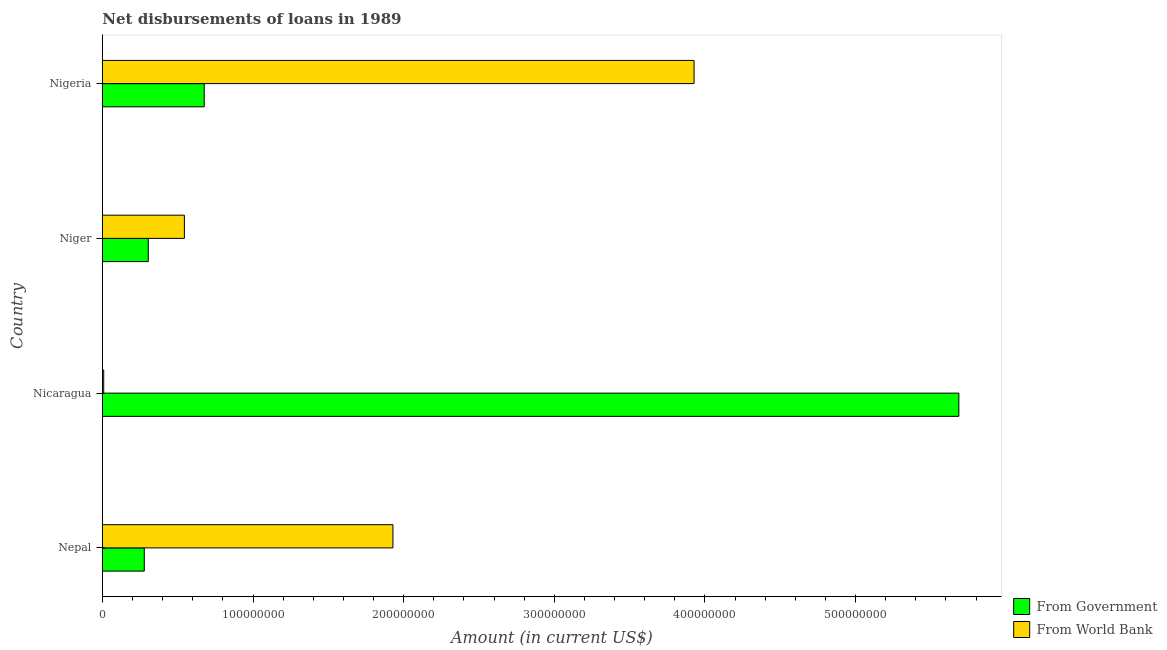How many different coloured bars are there?
Your response must be concise. 2. How many bars are there on the 3rd tick from the bottom?
Offer a terse response. 2. What is the label of the 4th group of bars from the top?
Provide a succinct answer. Nepal. What is the net disbursements of loan from world bank in Nigeria?
Offer a terse response. 3.93e+08. Across all countries, what is the maximum net disbursements of loan from government?
Keep it short and to the point. 5.69e+08. Across all countries, what is the minimum net disbursements of loan from world bank?
Offer a very short reply. 8.31e+05. In which country was the net disbursements of loan from world bank maximum?
Your response must be concise. Nigeria. In which country was the net disbursements of loan from world bank minimum?
Ensure brevity in your answer.  Nicaragua. What is the total net disbursements of loan from government in the graph?
Make the answer very short. 6.94e+08. What is the difference between the net disbursements of loan from government in Nicaragua and that in Niger?
Your response must be concise. 5.38e+08. What is the difference between the net disbursements of loan from world bank in Nigeria and the net disbursements of loan from government in Nicaragua?
Give a very brief answer. -1.76e+08. What is the average net disbursements of loan from government per country?
Provide a succinct answer. 1.74e+08. What is the difference between the net disbursements of loan from government and net disbursements of loan from world bank in Nepal?
Keep it short and to the point. -1.65e+08. What is the ratio of the net disbursements of loan from government in Nepal to that in Niger?
Ensure brevity in your answer.  0.91. What is the difference between the highest and the second highest net disbursements of loan from government?
Provide a short and direct response. 5.01e+08. What is the difference between the highest and the lowest net disbursements of loan from government?
Keep it short and to the point. 5.41e+08. In how many countries, is the net disbursements of loan from government greater than the average net disbursements of loan from government taken over all countries?
Your answer should be compact. 1. Is the sum of the net disbursements of loan from world bank in Nepal and Niger greater than the maximum net disbursements of loan from government across all countries?
Your answer should be compact. No. What does the 2nd bar from the top in Nigeria represents?
Provide a succinct answer. From Government. What does the 1st bar from the bottom in Niger represents?
Give a very brief answer. From Government. Are all the bars in the graph horizontal?
Ensure brevity in your answer.  Yes. How many countries are there in the graph?
Your answer should be compact. 4. What is the difference between two consecutive major ticks on the X-axis?
Keep it short and to the point. 1.00e+08. Does the graph contain any zero values?
Provide a succinct answer. No. Does the graph contain grids?
Make the answer very short. No. Where does the legend appear in the graph?
Keep it short and to the point. Bottom right. How many legend labels are there?
Your answer should be compact. 2. How are the legend labels stacked?
Offer a terse response. Vertical. What is the title of the graph?
Offer a terse response. Net disbursements of loans in 1989. What is the label or title of the Y-axis?
Your answer should be compact. Country. What is the Amount (in current US$) in From Government in Nepal?
Ensure brevity in your answer.  2.78e+07. What is the Amount (in current US$) of From World Bank in Nepal?
Your answer should be compact. 1.93e+08. What is the Amount (in current US$) in From Government in Nicaragua?
Provide a succinct answer. 5.69e+08. What is the Amount (in current US$) in From World Bank in Nicaragua?
Your answer should be very brief. 8.31e+05. What is the Amount (in current US$) of From Government in Niger?
Your answer should be compact. 3.04e+07. What is the Amount (in current US$) in From World Bank in Niger?
Provide a succinct answer. 5.44e+07. What is the Amount (in current US$) in From Government in Nigeria?
Provide a short and direct response. 6.76e+07. What is the Amount (in current US$) of From World Bank in Nigeria?
Your response must be concise. 3.93e+08. Across all countries, what is the maximum Amount (in current US$) of From Government?
Make the answer very short. 5.69e+08. Across all countries, what is the maximum Amount (in current US$) of From World Bank?
Provide a succinct answer. 3.93e+08. Across all countries, what is the minimum Amount (in current US$) in From Government?
Provide a short and direct response. 2.78e+07. Across all countries, what is the minimum Amount (in current US$) in From World Bank?
Your answer should be very brief. 8.31e+05. What is the total Amount (in current US$) in From Government in the graph?
Give a very brief answer. 6.94e+08. What is the total Amount (in current US$) of From World Bank in the graph?
Provide a short and direct response. 6.41e+08. What is the difference between the Amount (in current US$) of From Government in Nepal and that in Nicaragua?
Make the answer very short. -5.41e+08. What is the difference between the Amount (in current US$) in From World Bank in Nepal and that in Nicaragua?
Offer a very short reply. 1.92e+08. What is the difference between the Amount (in current US$) of From Government in Nepal and that in Niger?
Your response must be concise. -2.66e+06. What is the difference between the Amount (in current US$) in From World Bank in Nepal and that in Niger?
Your answer should be compact. 1.38e+08. What is the difference between the Amount (in current US$) of From Government in Nepal and that in Nigeria?
Keep it short and to the point. -3.98e+07. What is the difference between the Amount (in current US$) of From World Bank in Nepal and that in Nigeria?
Keep it short and to the point. -2.00e+08. What is the difference between the Amount (in current US$) in From Government in Nicaragua and that in Niger?
Provide a short and direct response. 5.38e+08. What is the difference between the Amount (in current US$) of From World Bank in Nicaragua and that in Niger?
Offer a terse response. -5.35e+07. What is the difference between the Amount (in current US$) in From Government in Nicaragua and that in Nigeria?
Your answer should be very brief. 5.01e+08. What is the difference between the Amount (in current US$) of From World Bank in Nicaragua and that in Nigeria?
Make the answer very short. -3.92e+08. What is the difference between the Amount (in current US$) in From Government in Niger and that in Nigeria?
Your answer should be compact. -3.71e+07. What is the difference between the Amount (in current US$) in From World Bank in Niger and that in Nigeria?
Provide a succinct answer. -3.38e+08. What is the difference between the Amount (in current US$) in From Government in Nepal and the Amount (in current US$) in From World Bank in Nicaragua?
Your response must be concise. 2.69e+07. What is the difference between the Amount (in current US$) in From Government in Nepal and the Amount (in current US$) in From World Bank in Niger?
Make the answer very short. -2.66e+07. What is the difference between the Amount (in current US$) in From Government in Nepal and the Amount (in current US$) in From World Bank in Nigeria?
Offer a very short reply. -3.65e+08. What is the difference between the Amount (in current US$) of From Government in Nicaragua and the Amount (in current US$) of From World Bank in Niger?
Your response must be concise. 5.14e+08. What is the difference between the Amount (in current US$) of From Government in Nicaragua and the Amount (in current US$) of From World Bank in Nigeria?
Provide a succinct answer. 1.76e+08. What is the difference between the Amount (in current US$) of From Government in Niger and the Amount (in current US$) of From World Bank in Nigeria?
Offer a very short reply. -3.62e+08. What is the average Amount (in current US$) of From Government per country?
Your response must be concise. 1.74e+08. What is the average Amount (in current US$) of From World Bank per country?
Your answer should be very brief. 1.60e+08. What is the difference between the Amount (in current US$) of From Government and Amount (in current US$) of From World Bank in Nepal?
Give a very brief answer. -1.65e+08. What is the difference between the Amount (in current US$) of From Government and Amount (in current US$) of From World Bank in Nicaragua?
Provide a short and direct response. 5.68e+08. What is the difference between the Amount (in current US$) in From Government and Amount (in current US$) in From World Bank in Niger?
Keep it short and to the point. -2.40e+07. What is the difference between the Amount (in current US$) of From Government and Amount (in current US$) of From World Bank in Nigeria?
Offer a very short reply. -3.25e+08. What is the ratio of the Amount (in current US$) of From Government in Nepal to that in Nicaragua?
Your response must be concise. 0.05. What is the ratio of the Amount (in current US$) of From World Bank in Nepal to that in Nicaragua?
Offer a terse response. 232.06. What is the ratio of the Amount (in current US$) in From Government in Nepal to that in Niger?
Provide a succinct answer. 0.91. What is the ratio of the Amount (in current US$) in From World Bank in Nepal to that in Niger?
Offer a terse response. 3.55. What is the ratio of the Amount (in current US$) in From Government in Nepal to that in Nigeria?
Give a very brief answer. 0.41. What is the ratio of the Amount (in current US$) in From World Bank in Nepal to that in Nigeria?
Make the answer very short. 0.49. What is the ratio of the Amount (in current US$) of From Government in Nicaragua to that in Niger?
Your response must be concise. 18.69. What is the ratio of the Amount (in current US$) of From World Bank in Nicaragua to that in Niger?
Offer a terse response. 0.02. What is the ratio of the Amount (in current US$) in From Government in Nicaragua to that in Nigeria?
Offer a terse response. 8.42. What is the ratio of the Amount (in current US$) of From World Bank in Nicaragua to that in Nigeria?
Your answer should be compact. 0. What is the ratio of the Amount (in current US$) of From Government in Niger to that in Nigeria?
Offer a terse response. 0.45. What is the ratio of the Amount (in current US$) of From World Bank in Niger to that in Nigeria?
Ensure brevity in your answer.  0.14. What is the difference between the highest and the second highest Amount (in current US$) of From Government?
Provide a short and direct response. 5.01e+08. What is the difference between the highest and the second highest Amount (in current US$) of From World Bank?
Your answer should be very brief. 2.00e+08. What is the difference between the highest and the lowest Amount (in current US$) of From Government?
Offer a very short reply. 5.41e+08. What is the difference between the highest and the lowest Amount (in current US$) of From World Bank?
Your answer should be compact. 3.92e+08. 